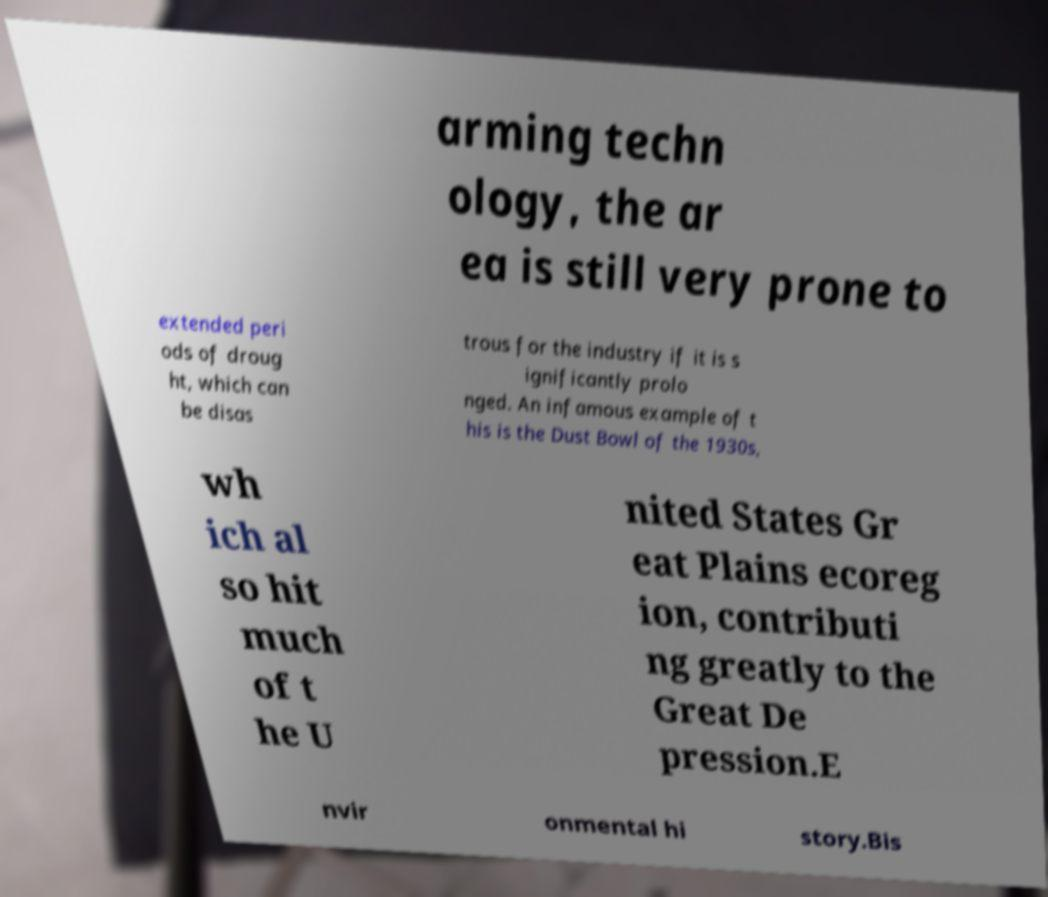Could you extract and type out the text from this image? arming techn ology, the ar ea is still very prone to extended peri ods of droug ht, which can be disas trous for the industry if it is s ignificantly prolo nged. An infamous example of t his is the Dust Bowl of the 1930s, wh ich al so hit much of t he U nited States Gr eat Plains ecoreg ion, contributi ng greatly to the Great De pression.E nvir onmental hi story.Bis 